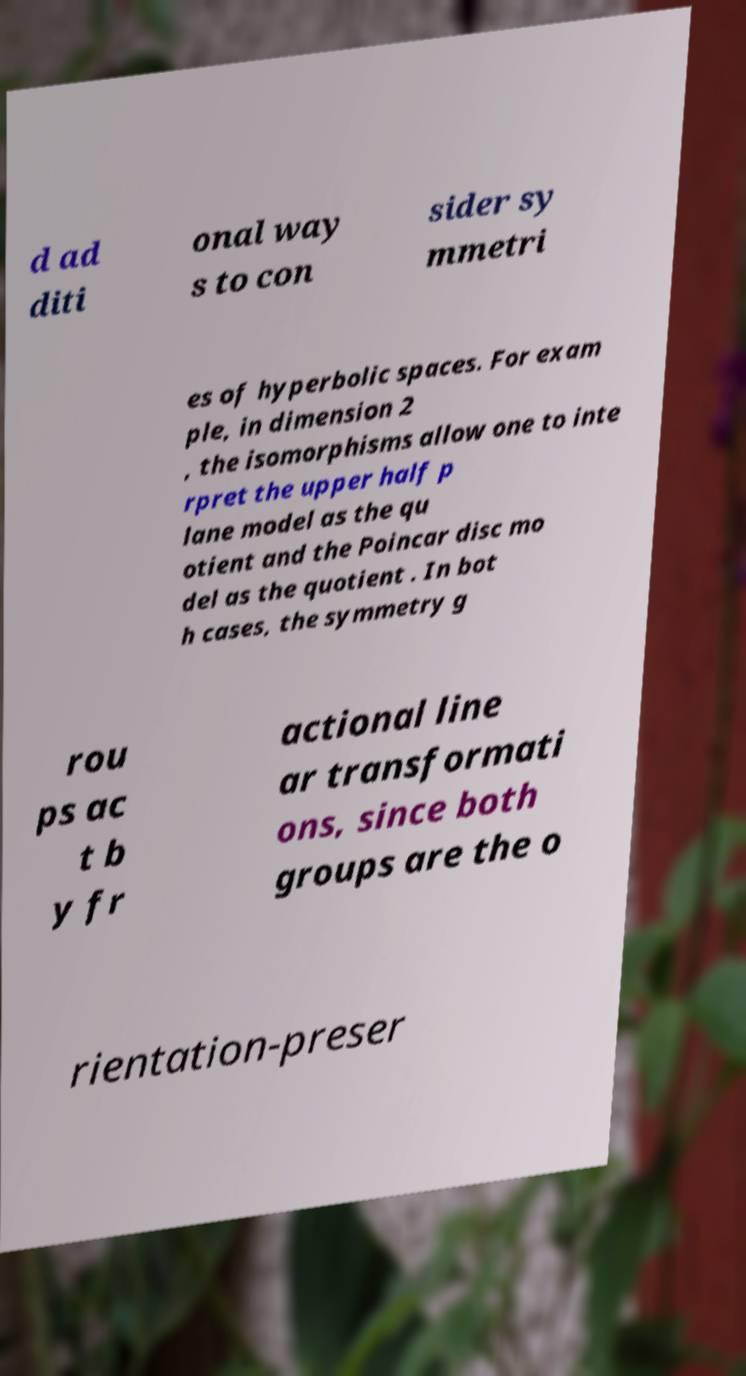Please identify and transcribe the text found in this image. d ad diti onal way s to con sider sy mmetri es of hyperbolic spaces. For exam ple, in dimension 2 , the isomorphisms allow one to inte rpret the upper half p lane model as the qu otient and the Poincar disc mo del as the quotient . In bot h cases, the symmetry g rou ps ac t b y fr actional line ar transformati ons, since both groups are the o rientation-preser 